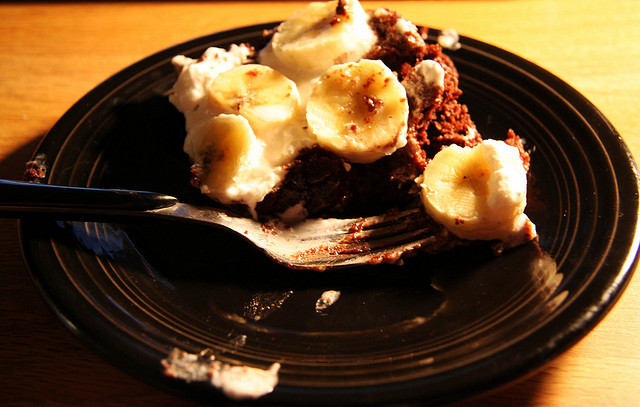How many bananas are there? 2 